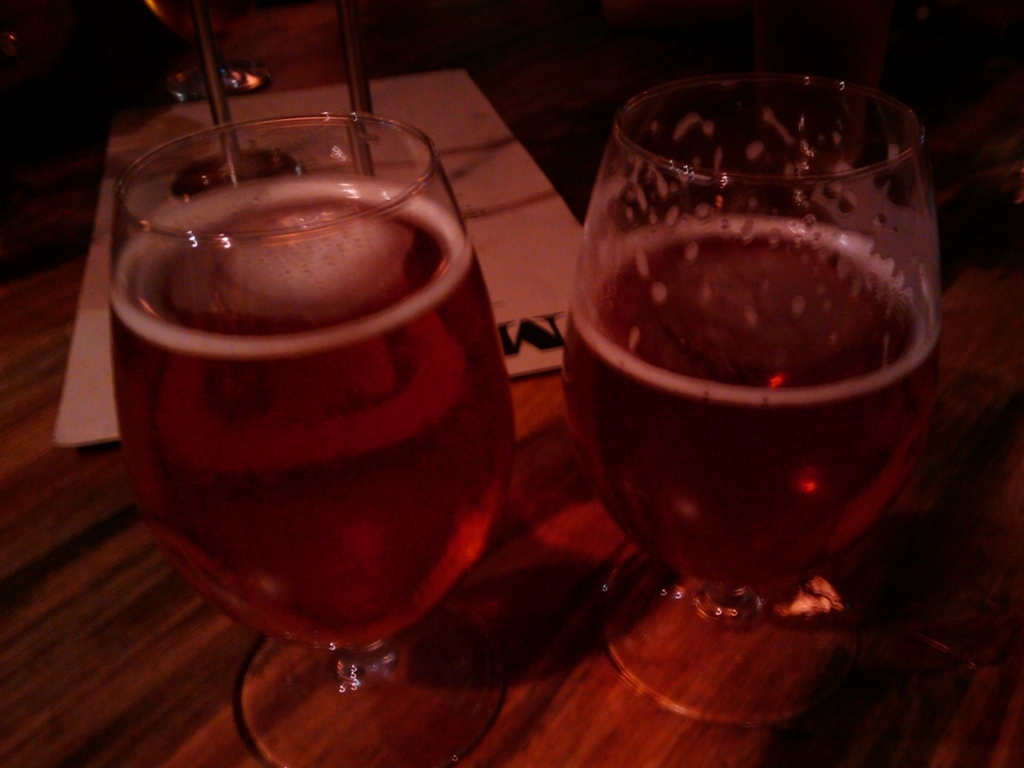Can you tell me what is in the glasses in the image? The glasses seem to contain a liquid, likely a type of beverage. Given the context and the color, it could be a form of beer, possibly an amber or red ale, but without further information, I cannot determine the exact type. 